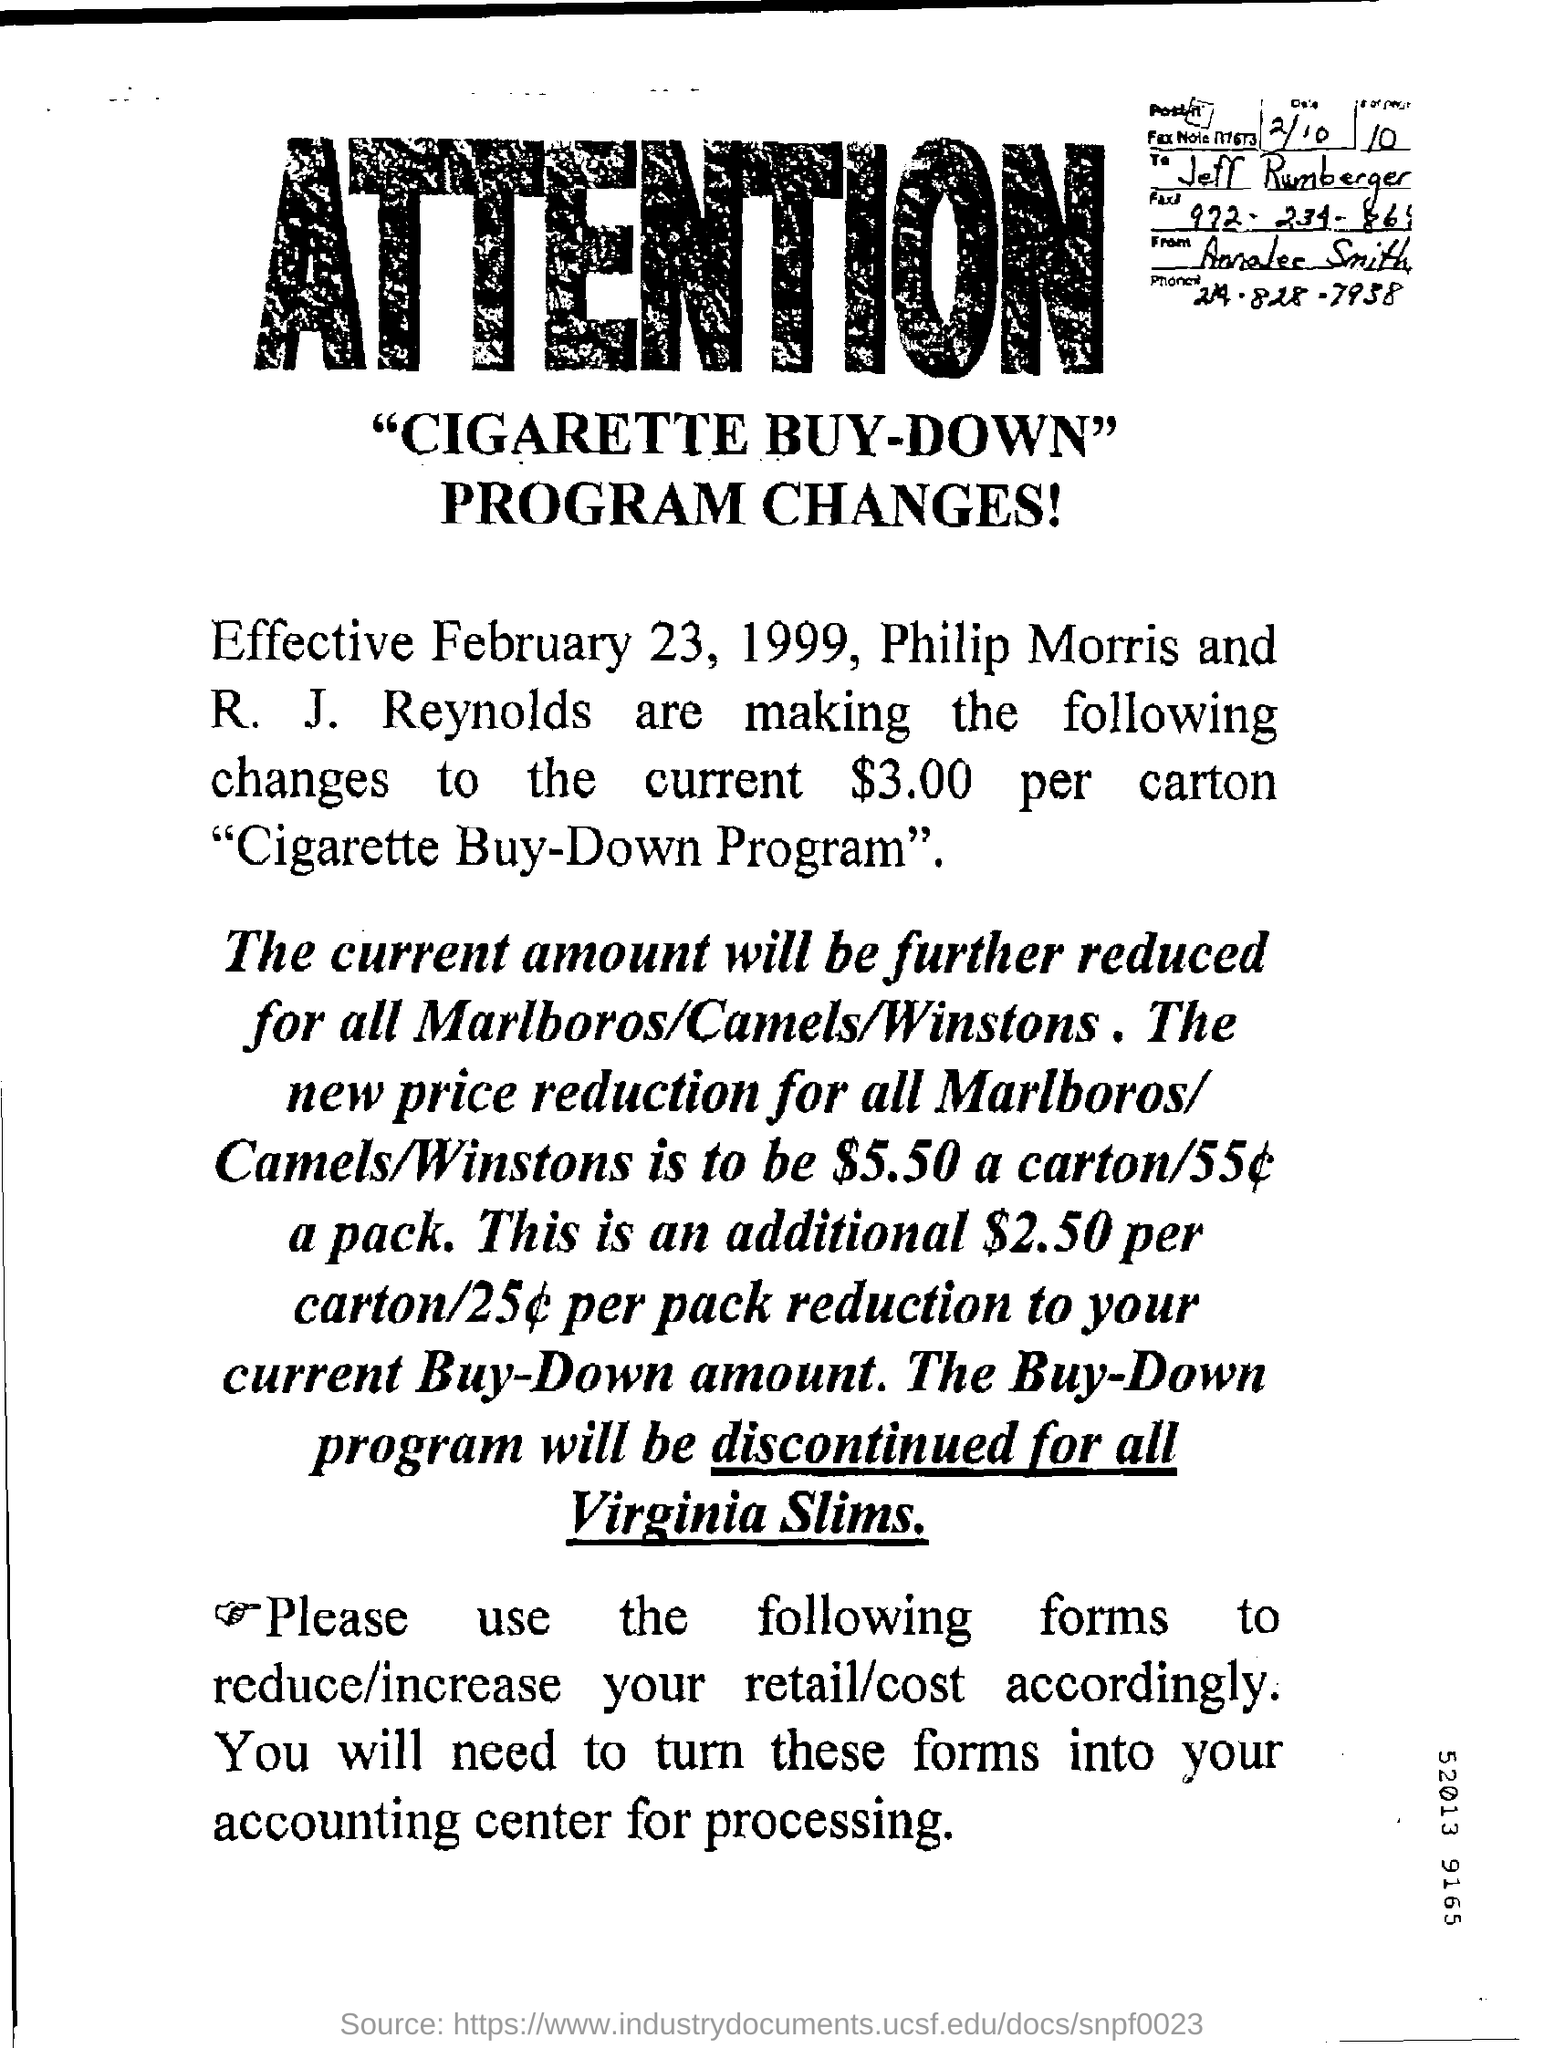Identify some key points in this picture. The program change became effective from February 23, 1999. The fax note is addressed to Jeff Rumberger. The Buy-Down Program for Virginia Slims cigarettes will be discontinued for all items. The current price per carton is $3.00. 